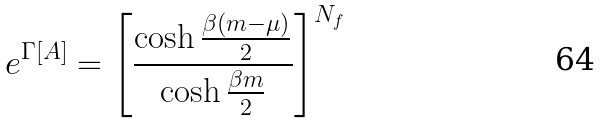Convert formula to latex. <formula><loc_0><loc_0><loc_500><loc_500>e ^ { \Gamma [ A ] } = \left [ \frac { \cosh \frac { \beta ( m - \mu ) } { 2 } } { \cosh \frac { \beta m } { 2 } } \right ] ^ { N _ { f } }</formula> 